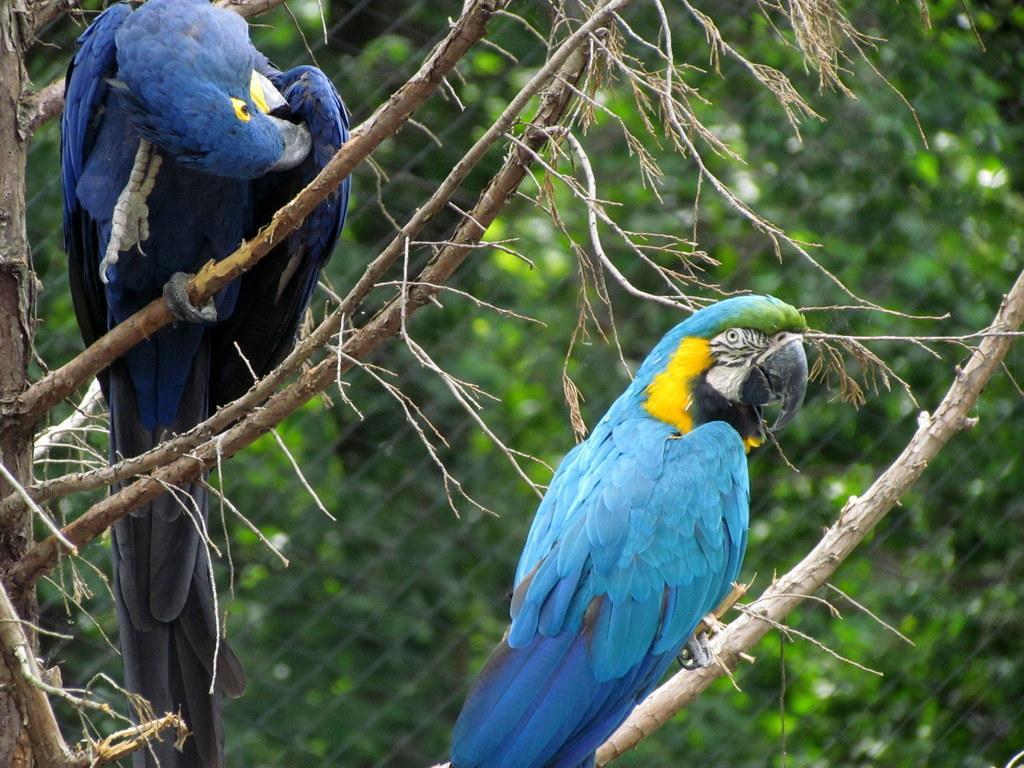Describe this image in one or two sentences. A blue color parrot is sitting on the branch of a tree. On the left side there is another parrot in dark blue color. 